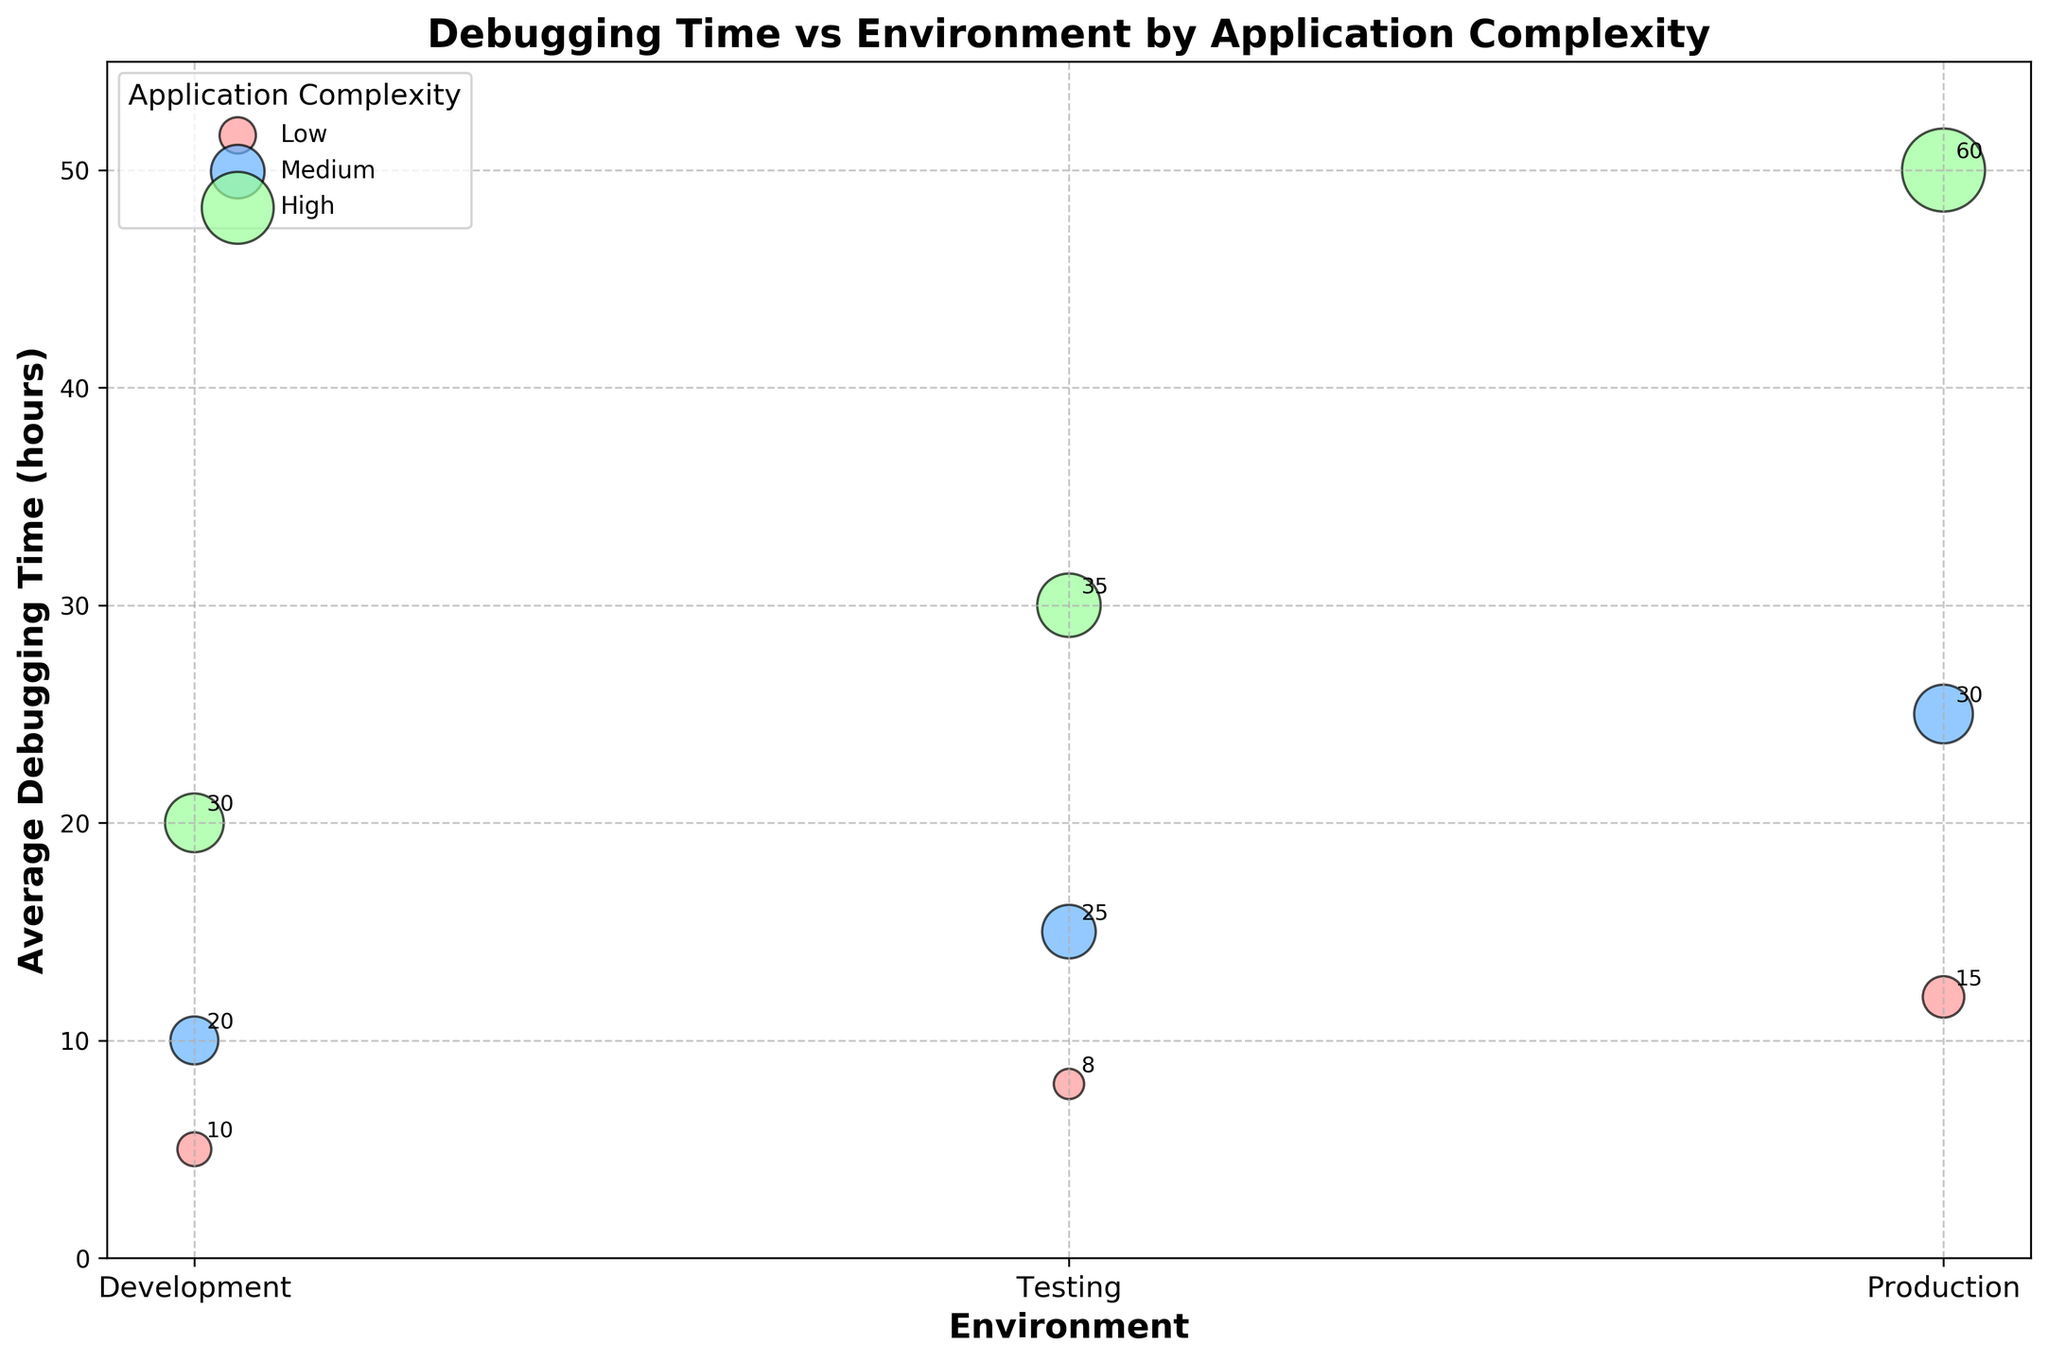what is the title of the plot? The title of a plot is typically found at the top center of the figure and provides a brief description of what the plot represents. In this case, it reads 'Debugging Time vs Environment by Application Complexity'.
Answer: Debugging Time vs Environment by Application Complexity how many different application complexities are displayed in the plot? The plot uses different colors to represent different application complexities. By observing the legend, one can identify the different categories. Here, there are three complexities: ‘Low’, ‘Medium’, and ‘High’.
Answer: 3 which environment has the highest average debugging time for high complexity applications? To find which environment has the highest debugging time for high complexity applications, one should look at the highest point on the y-axis for the 'High' category (colored accordingly). This occurs at the 'Production' environment.
Answer: Production what is the average debugging time for medium complexity applications in the testing environment? Locate the bubble corresponding to the 'Medium' complexity in the 'Testing' environment on the x-axis. Then, read off the corresponding y-axis value. It is indicated to be 15.
Answer: 15 how many issues are associated with low complexity applications in production? The figure annotates the number of issues in each bubble. By reading the annotation within the 'Low' complexity bubble at the 'Production' environment, one finds that it is 15.
Answer: 15 what is the difference in average debugging time between low and high complexity applications in development? Identify the y-axis values for both 'Low’ and 'High' complexity applications in the 'Development' environment. The difference is calculated by subtracting the 'Low' value (5) from the 'High' value (20), resulting in 15 hours.
Answer: 15 what is the sum of the number of issues in the testing environment across all application complexities? Summing the number of issues annotated in the testing bubbles for 'Low', 'Medium', and 'High' complexities (8 + 25 + 35) gives 68.
Answer: 68 compare the debugging time of medium complexity in development versus in production. By comparing the y-axis values of 'Medium' complexity in both 'Development' (10) and 'Production' (25) environments, it is evident that the debugging time in 'Production' is higher by 15 hours.
Answer: Production is higher by 15 hours which application complexity shows the largest bubble in the production environment, and what does it signify? The bubble size corresponds to the number of issues. The largest bubble in the 'Production' environment is 'High' complexity, signified by its annotation (60 issues).
Answer: High complexity, 60 issues how does the size of bubbles change with increasing application complexity in the same environment (e.g., Development)? Comparing the bubble sizes in the 'Development' environment for 'Low', 'Medium', and 'High' complexities, one can see that the bubble size increases with complexity, indicating an increase in the number of issues: 10, 20, and 30 respectively.
Answer: Increases 